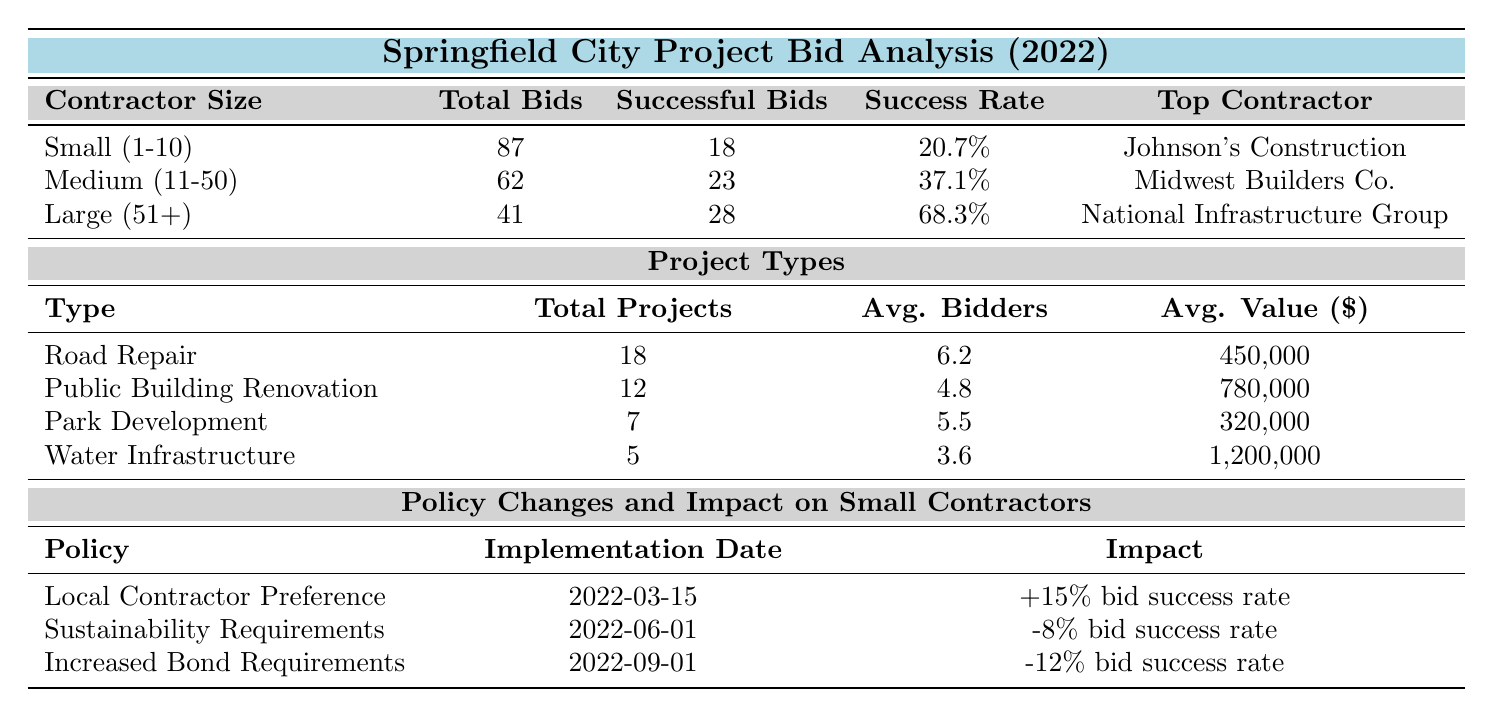What is the success rate for large contractors? The success rate for large contractors, which is categorized as having 51 or more employees, is stated directly in the table under the success rate column. It shows 68.3% for large contractors.
Answer: 68.3% How many successful bids did medium contractors have? The table lists the number of successful bids for medium contractors, defined as those with 11 to 50 employees, which is 23 successful bids.
Answer: 23 What is the average project value for public building renovation projects? The average project value for public building renovation is found in the project types section of the table, which states it as 780,000.
Answer: 780,000 What is the total number of bids submitted by small contractors? Looking in the contractor categories section, the total number of bids submitted by small contractors is provided as 87.
Answer: 87 Which contractor had the highest average project value in the large category? The table shows the top contractors in the large category and provides their average project values. National Infrastructure Group has the highest average project value listed at 2,100,000.
Answer: National Infrastructure Group How does the implementation of "Increased Bond Requirements" affect small contractors' bid success rates? The table details that "Increased Bond Requirements" have a negative impact of -12% on small contractors' bid success rates. This means small contractors' success rates will decrease by 12% due to this policy change.
Answer: -12% impact What is the difference in success rates between small and medium contractors? The success rate for small contractors is 20.7%, and for medium contractors, it is 37.1%. The difference can be calculated as 37.1% - 20.7% = 16.4%.
Answer: 16.4% How many total projects fall under the category of water infrastructure? The total number of water infrastructure projects is listed in the project types section of the table, where it indicates that there are 5 total projects.
Answer: 5 Which policy change resulted in the highest impact on small contractors' bid success rates? Reviewing the policy changes, "Local Contractor Preference" resulted in a +15% increase, while "Sustainability Requirements" and "Increased Bond Requirements" had negative impacts. The highest impacting policy is therefore the first one.
Answer: Local Contractor Preference What is the total average project value across all project types listed in the table? To find the total average project value, we calculate the average of the values provided for each project type (450,000 + 780,000 + 320,000 + 1,200,000) = 2,750,000. Then divide by the number of project types (4), which gives us an average of 687,500.
Answer: 687,500 